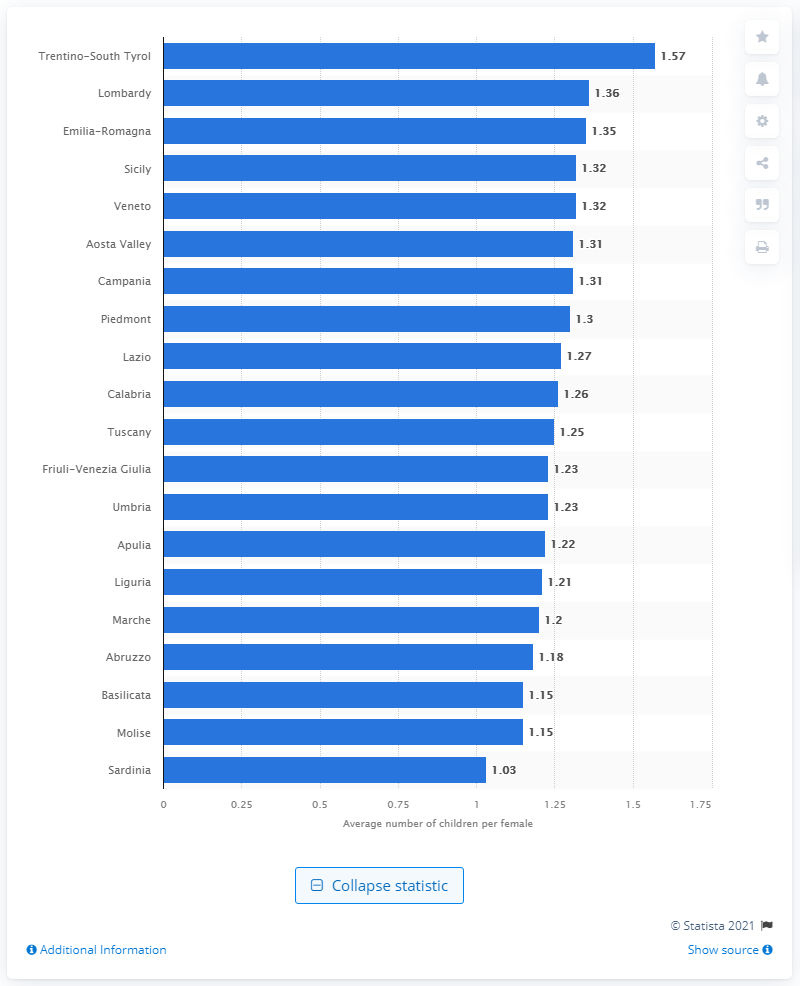Mention a couple of crucial points in this snapshot. In 2019, the region of Trentino-South Tyrol in Italy had the highest fertility rate among all regions in the country. In 2019, the average number of children born per female in the region of Trentino-South Tyrol was 1.57. 